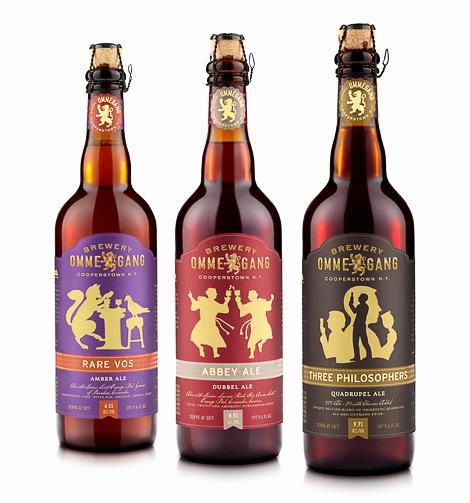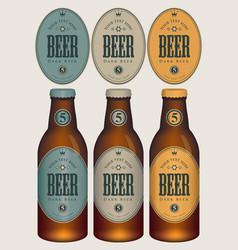The first image is the image on the left, the second image is the image on the right. For the images shown, is this caption "Each image contains exactly three bottles." true? Answer yes or no. Yes. The first image is the image on the left, the second image is the image on the right. Analyze the images presented: Is the assertion "At least eight bottles of beer are shown." valid? Answer yes or no. No. 